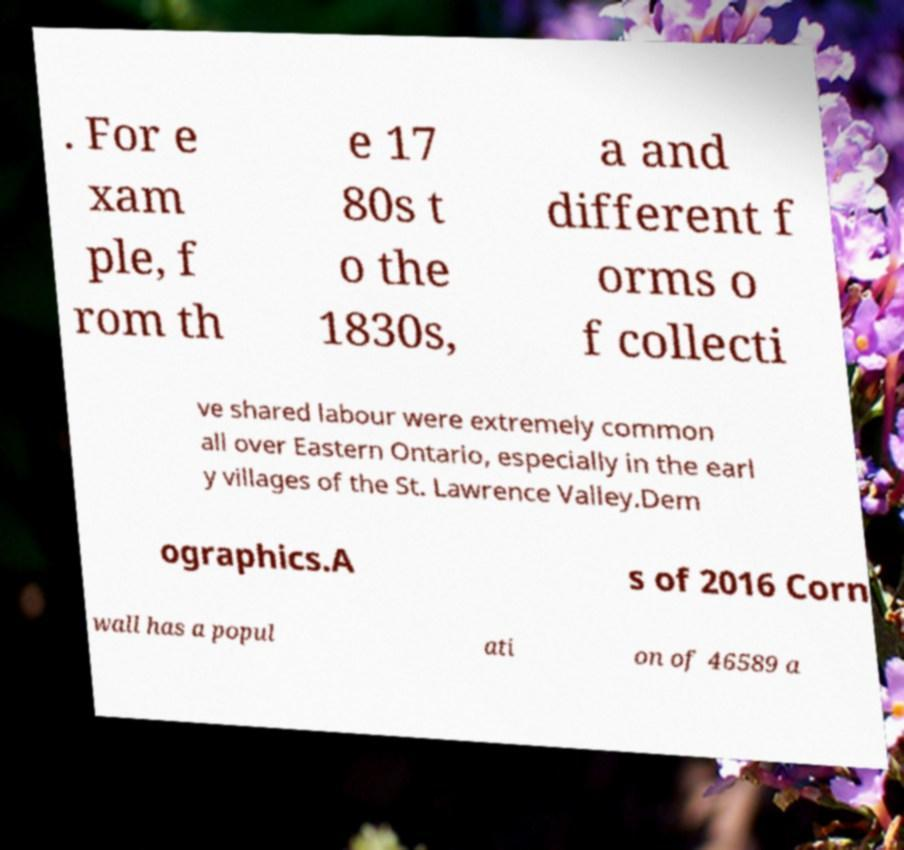Could you extract and type out the text from this image? . For e xam ple, f rom th e 17 80s t o the 1830s, a and different f orms o f collecti ve shared labour were extremely common all over Eastern Ontario, especially in the earl y villages of the St. Lawrence Valley.Dem ographics.A s of 2016 Corn wall has a popul ati on of 46589 a 